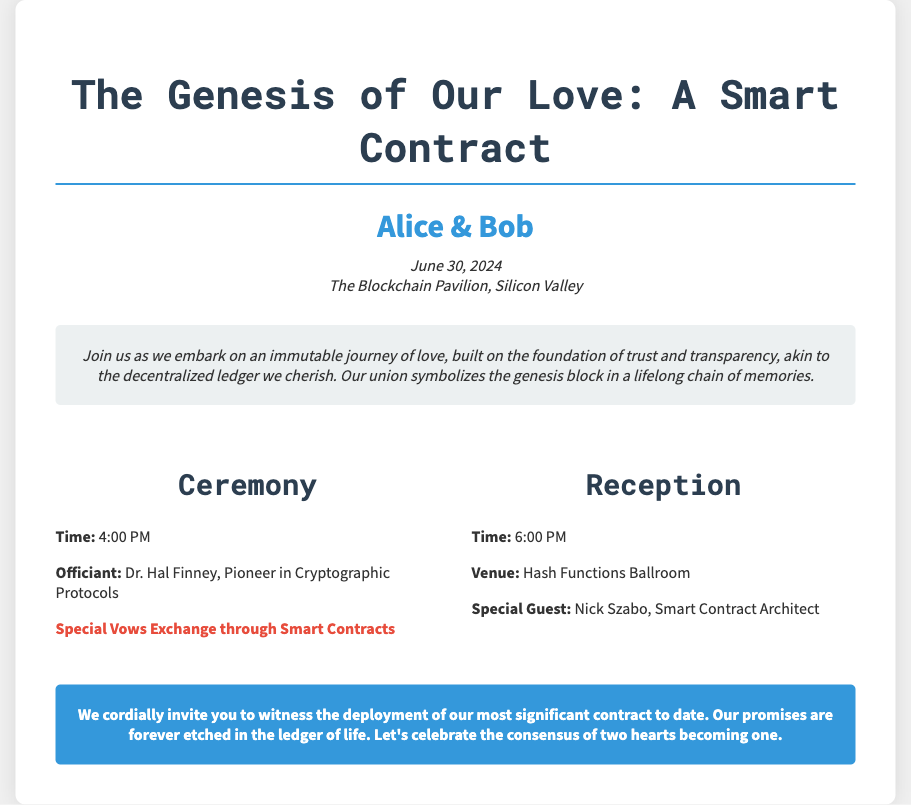What is the names of the couple? The names of the couple are highlighted in the invitation, listed as "Alice & Bob."
Answer: Alice & Bob What is the date of the wedding? The wedding date is mentioned in the document, specifically noted under the date location section.
Answer: June 30, 2024 What time does the ceremony start? The time for the ceremony is explicitly stated in the ceremony details.
Answer: 4:00 PM Who is officiating the ceremony? The officiant for the ceremony is identified in the ceremony details section.
Answer: Dr. Hal Finney Where is the reception taking place? The venue for the reception is clearly mentioned in the reception details area.
Answer: Hash Functions Ballroom What is unique about the vows exchange? A highlight in the ceremony details specifies a distinctive feature about the vows exchange.
Answer: Special Vows Exchange through Smart Contracts What is the purpose of the document? The introduction provides insight into the overall purpose of the invitation, framing it as a significant event.
Answer: Deployment of our most significant contract Who is a special guest at the reception? The document mentions a special guest under the reception details.
Answer: Nick Szabo What theme is used to describe the couple's union? The introduction uses specific terminology related to blockchain to describe the couple's love.
Answer: Immutable journey of love 